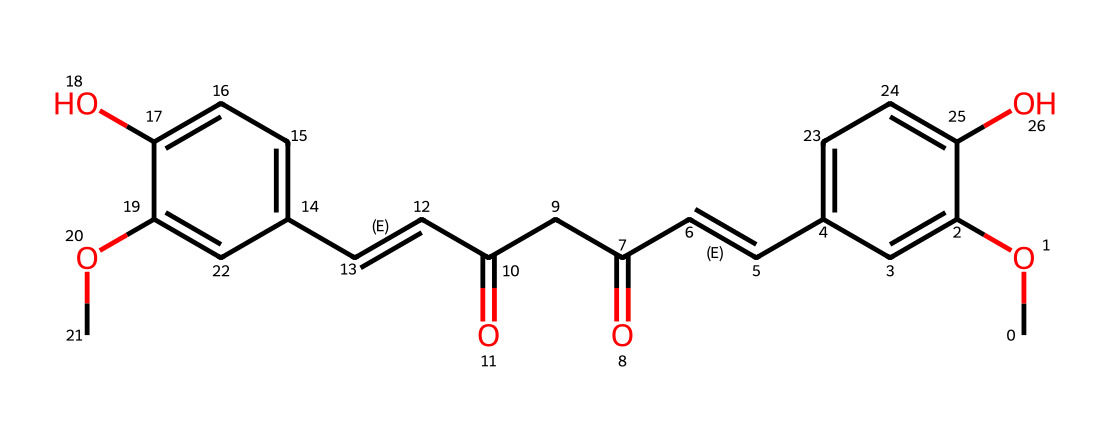What is the molecular formula of curcumin? To identify the molecular formula, we analyze the SMILES representation to count the number of each type of atom present. From the structure, we find 21 carbons (C), 20 hydrogens (H), and 6 oxygens (O), leading to the formula C21H20O6.
Answer: C21H20O6 How many hydroxyl (-OH) groups are present in curcumin? By examining the structure, we can see that there are two -OH groups indicated by the presence of oxygen atoms bonded to hydrogen in the structure of curcumin.
Answer: 2 What type of functional groups can be identified in the structure of curcumin? Analyzing the chemical structure, we can identify hydroxyl (-OH) groups, carbonyl (C=O) groups, and double bonds (C=C) as the notable functional groups present in curcumin.
Answer: hydroxyl, carbonyl, and double bonds Does curcumin contain any rings in its structure? By visual inspection of the SMILES representation, we note that there are no closed loops or cycles within the structure of curcumin; it is primarily a linear and branched molecule without rings.
Answer: No What is the significance of the double bonds in curcumin's molecular structure? The double bonds (C=C) contribute to the unsaturation and reactivity of the molecule, allowing it to potentially act as an antioxidant and to stabilize free radicals, which is significant for its preservative properties.
Answer: Antioxidant How many conjugated double bonds does curcumin have in its structure? In the SMILES representation, we can see alternating double bonds in the extended carbon chain, which indicates that curcumin has three conjugated double bonds based on the system of alternating single and double bonds.
Answer: 3 Which part of the curcumin structure contributes to its yellow color? The conjugated double bonds and the arrangement of the functional groups, particularly the extended system in the β-diketone structure, absorb specific wavelengths of light, resulting in the vivid yellow color associated with curcumin.
Answer: β-diketone structure 